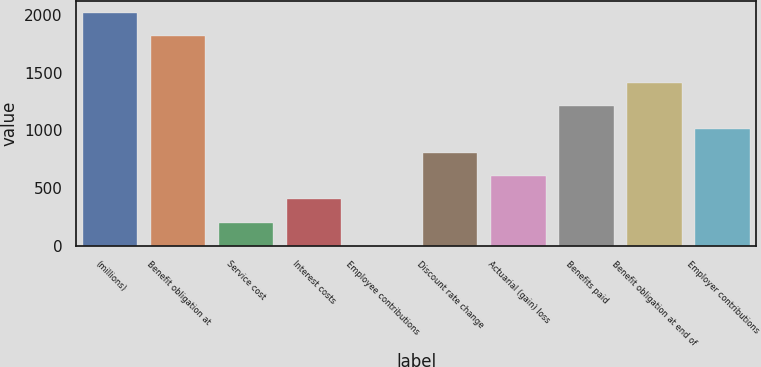<chart> <loc_0><loc_0><loc_500><loc_500><bar_chart><fcel>(millions)<fcel>Benefit obligation at<fcel>Service cost<fcel>Interest costs<fcel>Employee contributions<fcel>Discount rate change<fcel>Actuarial (gain) loss<fcel>Benefits paid<fcel>Benefit obligation at end of<fcel>Employer contributions<nl><fcel>2018<fcel>1816.24<fcel>202.16<fcel>403.92<fcel>0.4<fcel>807.44<fcel>605.68<fcel>1210.96<fcel>1412.72<fcel>1009.2<nl></chart> 